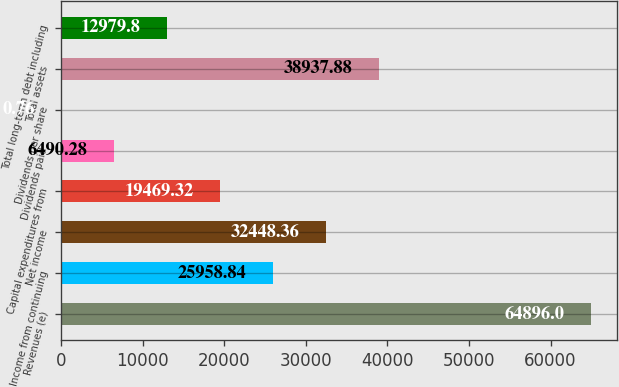<chart> <loc_0><loc_0><loc_500><loc_500><bar_chart><fcel>Revenues (e)<fcel>Income from continuing<fcel>Net income<fcel>Capital expenditures from<fcel>Dividends paid<fcel>Dividends per share<fcel>Total assets<fcel>Total long-term debt including<nl><fcel>64896<fcel>25958.8<fcel>32448.4<fcel>19469.3<fcel>6490.28<fcel>0.76<fcel>38937.9<fcel>12979.8<nl></chart> 